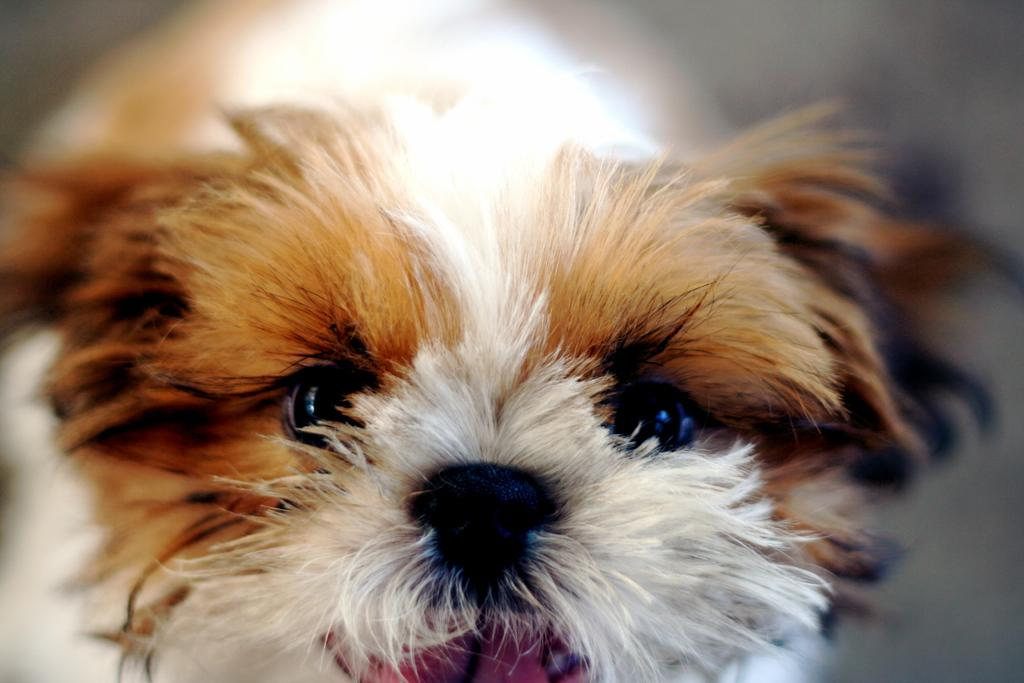What type of animal is present in the image? There is a dog with fur in the image. Can you describe the background of the image? The background of the image is blurred. What type of sweater is the dog wearing in the image? There is no sweater present in the image; the dog is depicted with fur. 